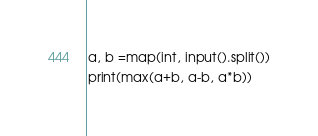Convert code to text. <code><loc_0><loc_0><loc_500><loc_500><_Python_>a, b =map(int, input().split())
print(max(a+b, a-b, a*b))</code> 